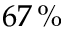Convert formula to latex. <formula><loc_0><loc_0><loc_500><loc_500>6 7 \, \%</formula> 